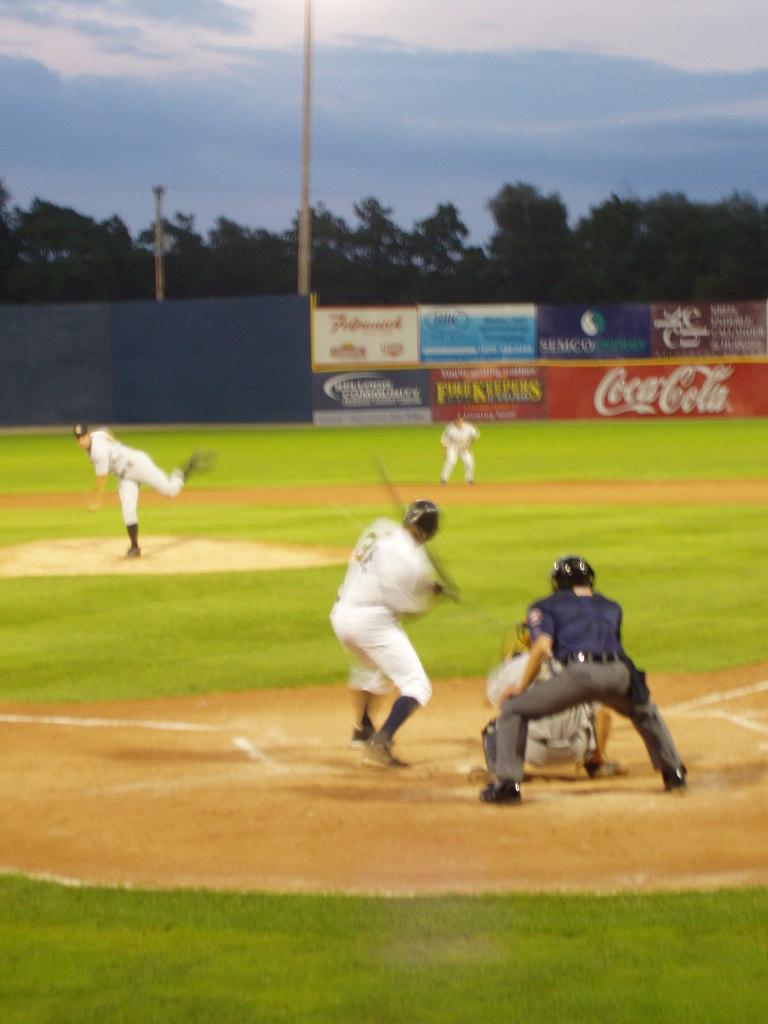What beverage brand is at the back of the field?
Keep it short and to the point. Coca cola. 